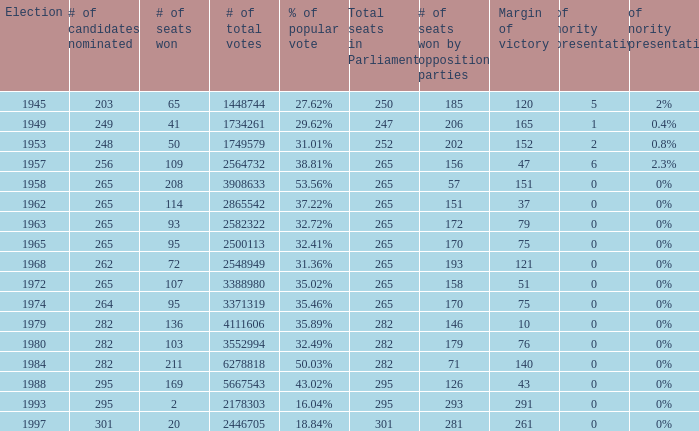What was the lowest # of total votes? 1448744.0. 